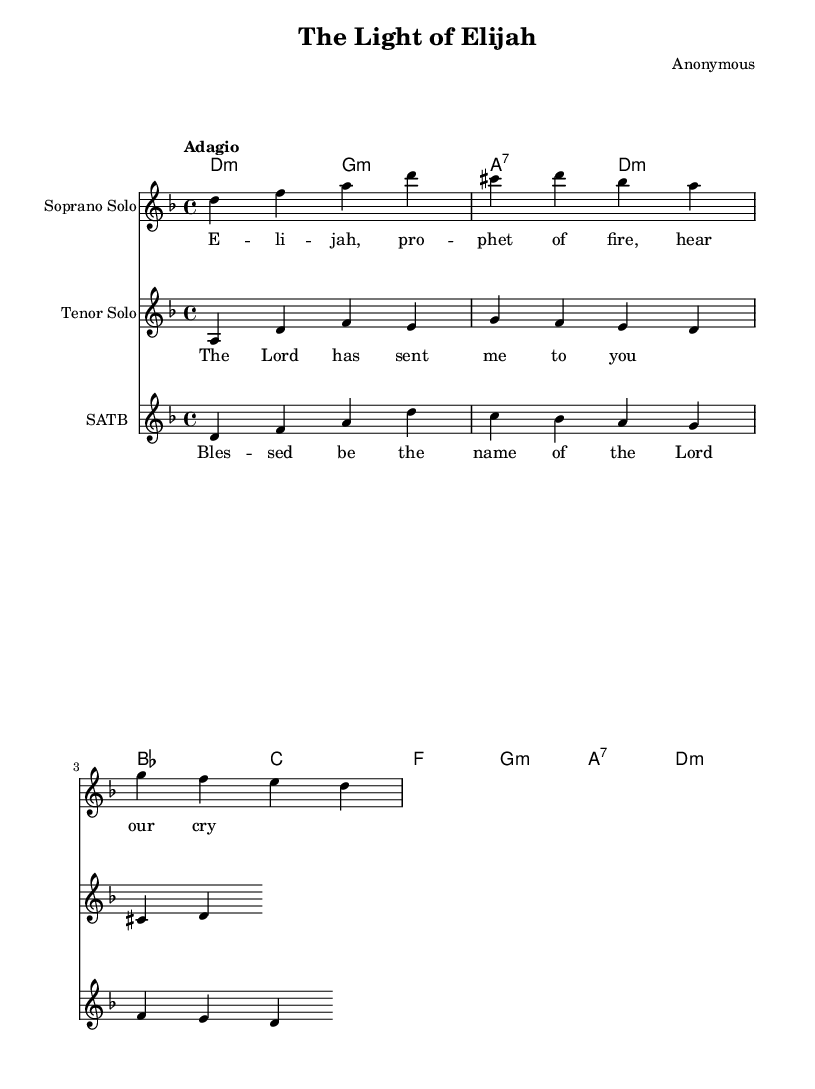What is the key signature of this music? The key signature is D minor, which has one flat (B flat).
Answer: D minor What is the time signature of this piece? The time signature appears at the beginning and is indicated as 4/4, which means four beats per measure.
Answer: 4/4 What is the tempo marking for this piece? The tempo marking is "Adagio", suggesting a slow pace of the piece.
Answer: Adagio How many soloists are featured in this score? There are two soloists mentioned in the score: a Soprano Solo and a Tenor Solo.
Answer: Two Which Biblical figure is the focus of the soprano solo lyrics? The soprano solo lyrics mention "Elijah," who is a significant prophet in the Old Testament.
Answer: Elijah What is the name of the piece? The title of the piece is "The Light of Elijah," indicating a thematic connection to the story of Elijah.
Answer: The Light of Elijah What is the overall structure of the choir voice parts indicated? The choir is indicated as "SATB," which stands for Soprano, Alto, Tenor, and Bass voice parts.
Answer: SATB 